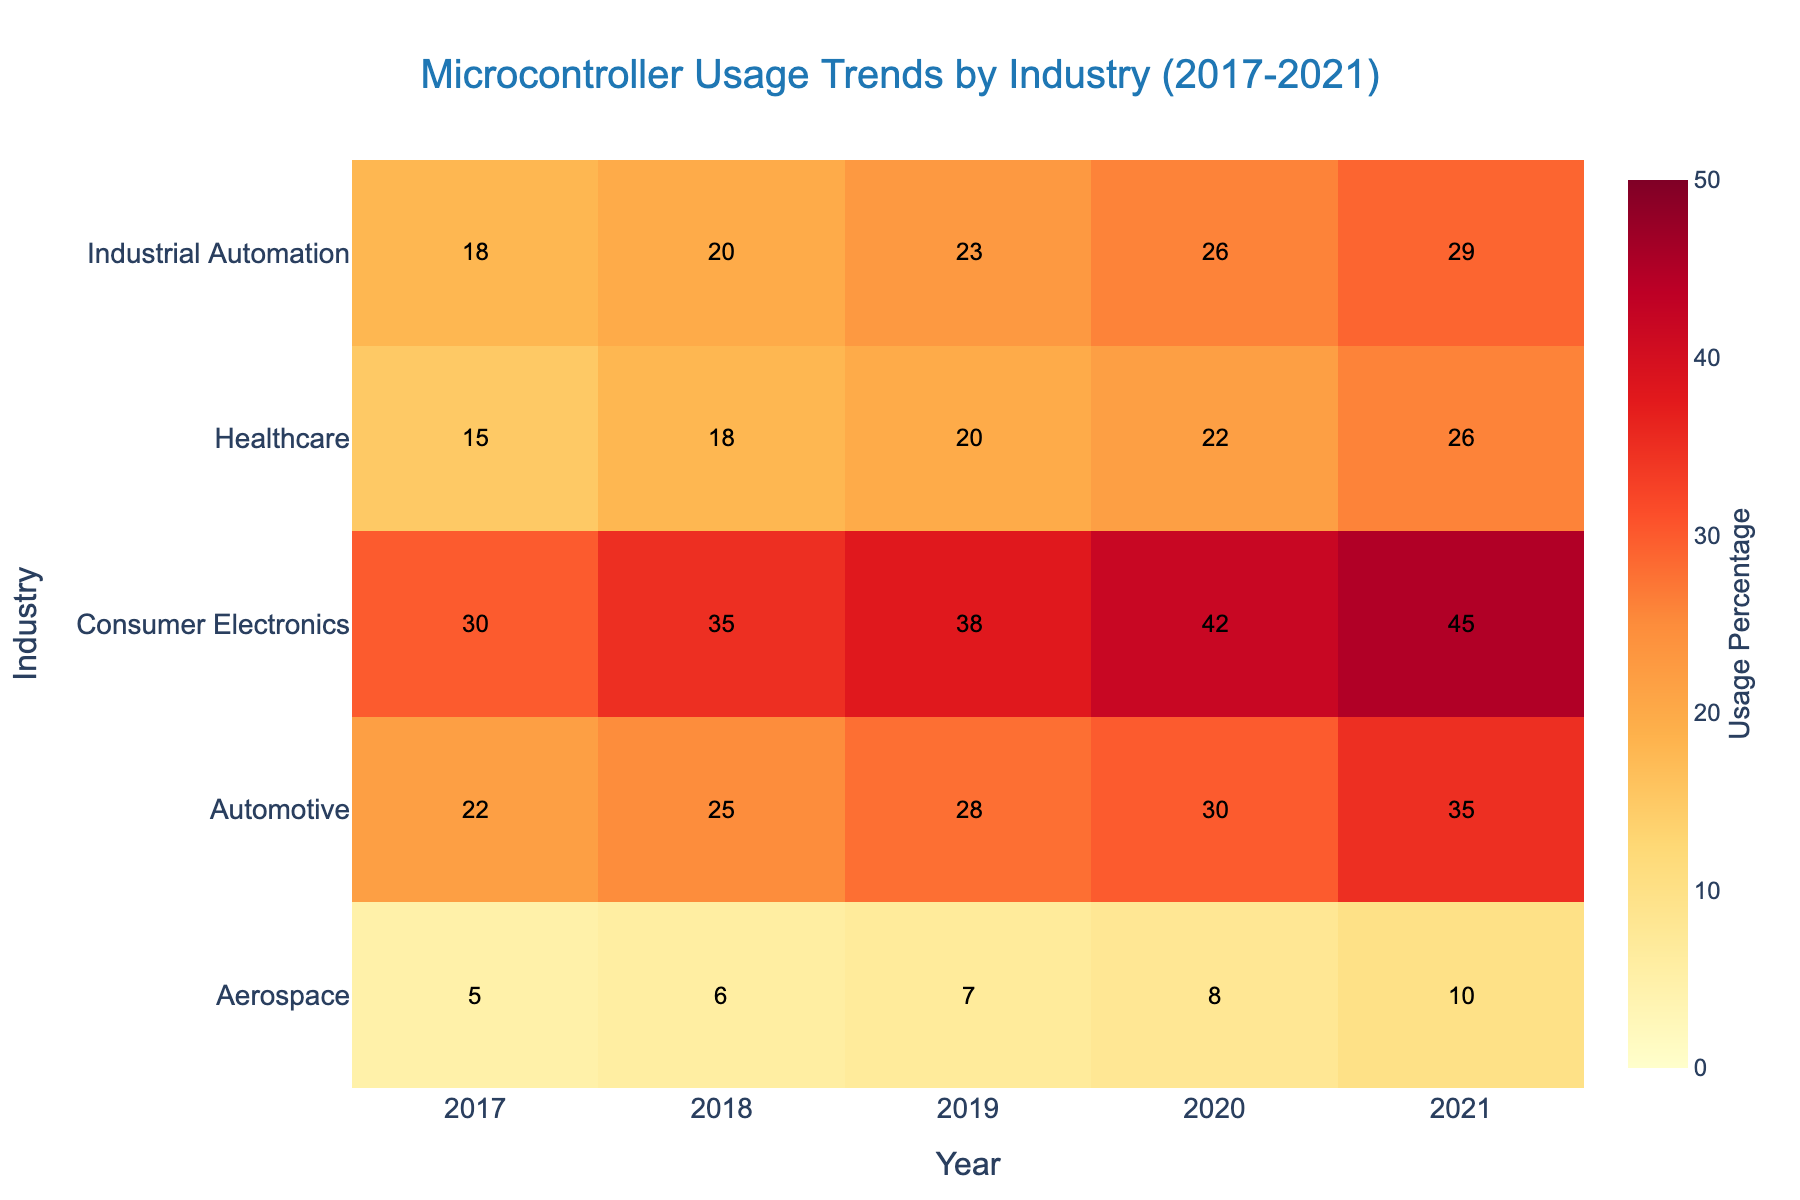what is the title of the figure? The title is typically located at the top of the figure and summarizes what the data represents. In this case, it is clearly written as "Microcontroller Usage Trends by Industry (2017-2021)".
Answer: Microcontroller Usage Trends by Industry (2017-2021) which industry had the highest microcontroller usage in 2021? In 2021, we look for the highest value on the heatmap for that year. The darkest color, representing the highest value, is found in the "Consumer Electronics" row.
Answer: Consumer Electronics how did the automotive industry's microcontroller usage change from 2017 to 2021? Start by finding the two values for 2017 and 2021 in the "Automotive" row, which are 22 and 35 respectively. Calculate the change: 35 - 22 = 13.
Answer: Increased by 13 points which year saw the lowest microcontroller usage in aerospace? Look at the "Aerospace" row and find the lowest value among the years displayed. The lowest value is 5, which is in the year 2017.
Answer: 2017 compare the microcontroller usage between healthcare and industrial automation in 2019 Find the values for Healthcare and Industrial Automation in 2019, which are 20 and 23 respectively. Compare them: 23 is greater than 20.
Answer: Industrial Automation has higher usage what is the average microcontroller usage in the consumer electronics industry over the years? Find the values in the "Consumer Electronics" row: 30, 35, 38, 42, and 45. Compute the average: (30 + 35 + 38 + 42 + 45) / 5 = 38.
Answer: 38 which industry showed the most significant increase in microcontroller usage over the period? Calculate the difference for each industry between 2017 and 2021. Automotive: 13 points, Consumer Electronics: 15 points, Healthcare: 11 points, Industrial Automation: 11 points, Aerospace: 5 points. The highest increase is in Consumer Electronics with 15 points.
Answer: Consumer Electronics what percentage did industrial automation usage increase from 2017 to 2020? Find the values for 2017 and 2020 in the Industrial Automation row: 18 and 26. Calculate the increase: (26 - 18) / 18 * 100% = 44.44%.
Answer: 44.44% which year had the overall highest usage across all industries? Identify the year with the darkest overall shading. A visual inspection shows the highest usage percentages overall occur in 2021.
Answer: 2021 